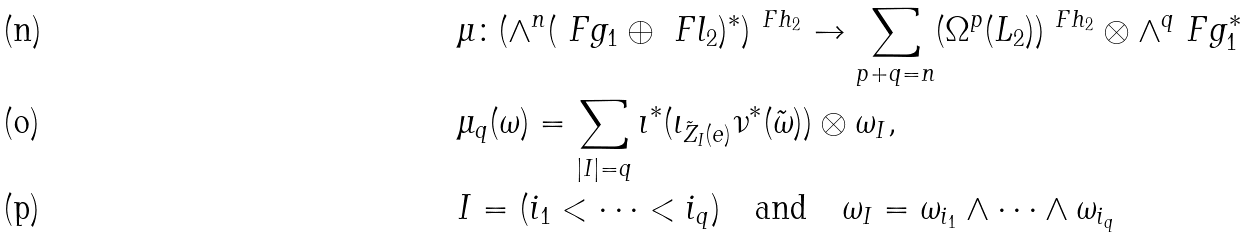<formula> <loc_0><loc_0><loc_500><loc_500>& \mu \colon ( \wedge ^ { n } ( \ F g _ { 1 } \oplus \ F l _ { 2 } ) ^ { \ast } ) ^ { \ F h _ { 2 } } \to \sum _ { p + q = n } ( \Omega ^ { p } ( L _ { 2 } ) ) ^ { \ F h _ { 2 } } \otimes \wedge ^ { q } \ F g _ { 1 } ^ { \ast } \\ & \mu _ { q } ( \omega ) = \sum _ { | I | = q } \imath ^ { \ast } ( \iota _ { \tilde { Z } _ { I } ( e ) } \nu ^ { \ast } ( \tilde { \omega } ) ) \otimes \omega _ { I } , \\ & I = ( i _ { 1 } < \dots < i _ { q } ) \quad \text {and} \quad \omega _ { I } = \omega _ { i _ { 1 } } \wedge \cdots \wedge \omega _ { i _ { q } }</formula> 